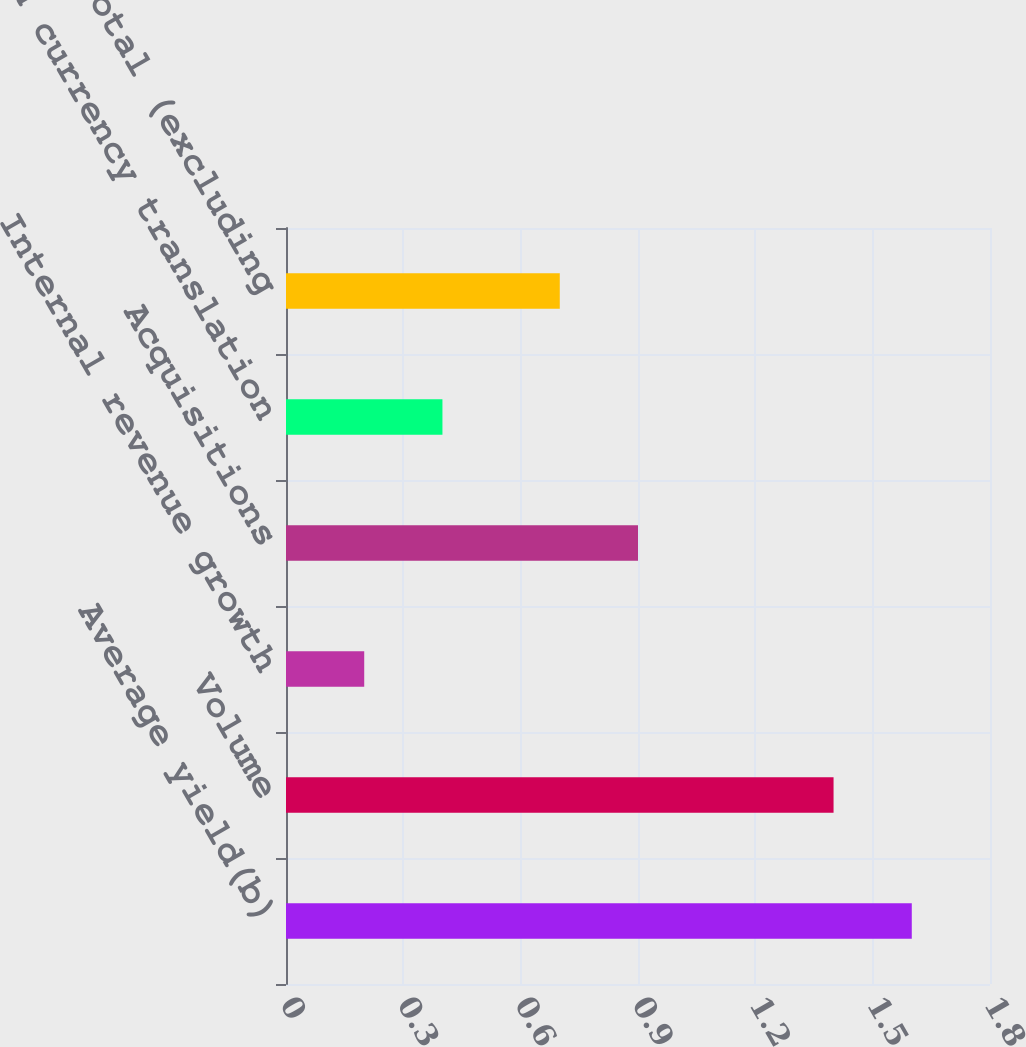Convert chart to OTSL. <chart><loc_0><loc_0><loc_500><loc_500><bar_chart><fcel>Average yield(b)<fcel>Volume<fcel>Internal revenue growth<fcel>Acquisitions<fcel>Foreign currency translation<fcel>Subtotal (excluding<nl><fcel>1.6<fcel>1.4<fcel>0.2<fcel>0.9<fcel>0.4<fcel>0.7<nl></chart> 